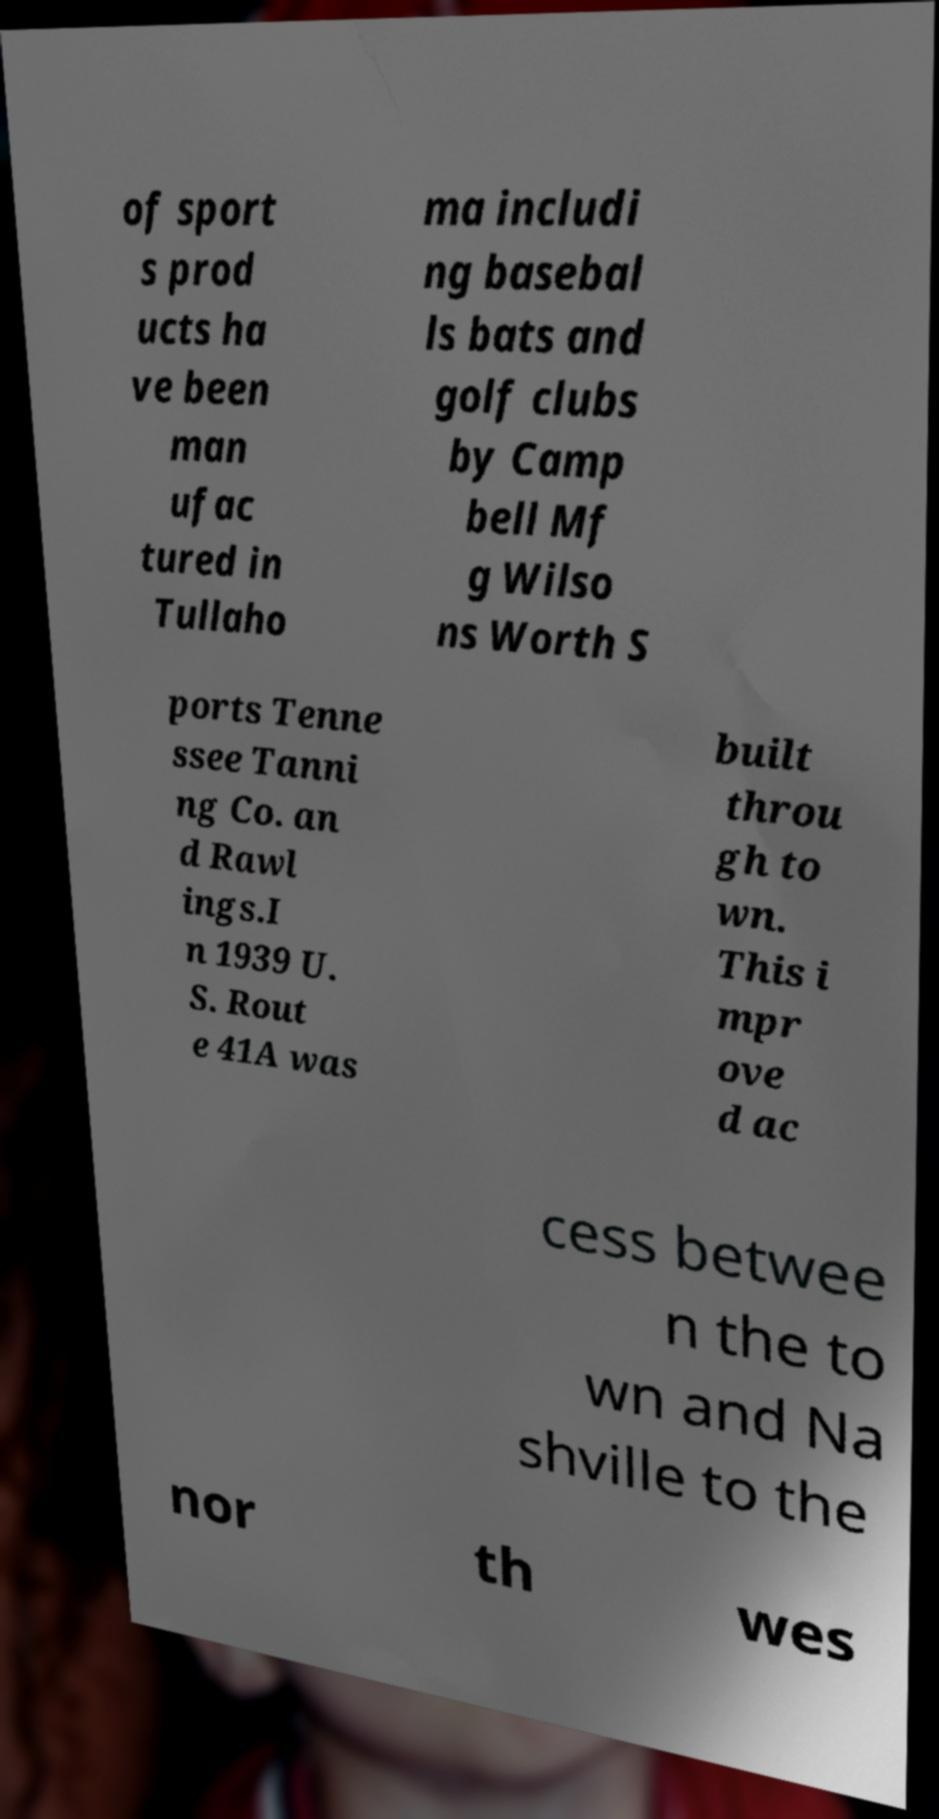What messages or text are displayed in this image? I need them in a readable, typed format. of sport s prod ucts ha ve been man ufac tured in Tullaho ma includi ng basebal ls bats and golf clubs by Camp bell Mf g Wilso ns Worth S ports Tenne ssee Tanni ng Co. an d Rawl ings.I n 1939 U. S. Rout e 41A was built throu gh to wn. This i mpr ove d ac cess betwee n the to wn and Na shville to the nor th wes 